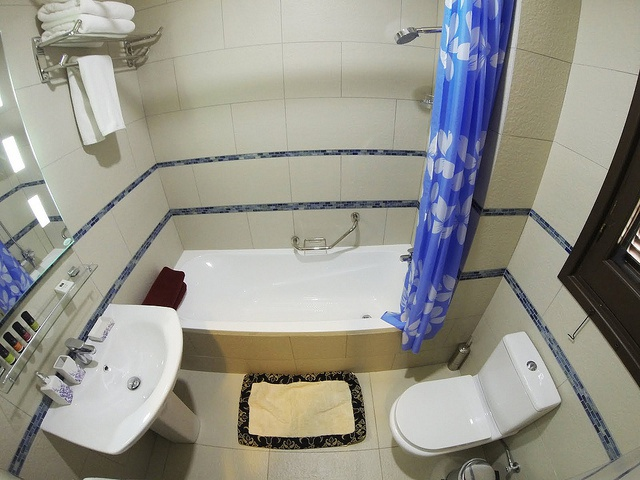Describe the objects in this image and their specific colors. I can see sink in gray, lightgray, darkgray, and black tones, toilet in gray, lightgray, and darkgray tones, bottle in gray and black tones, bottle in gray, black, darkgray, and brown tones, and bottle in gray, black, and olive tones in this image. 